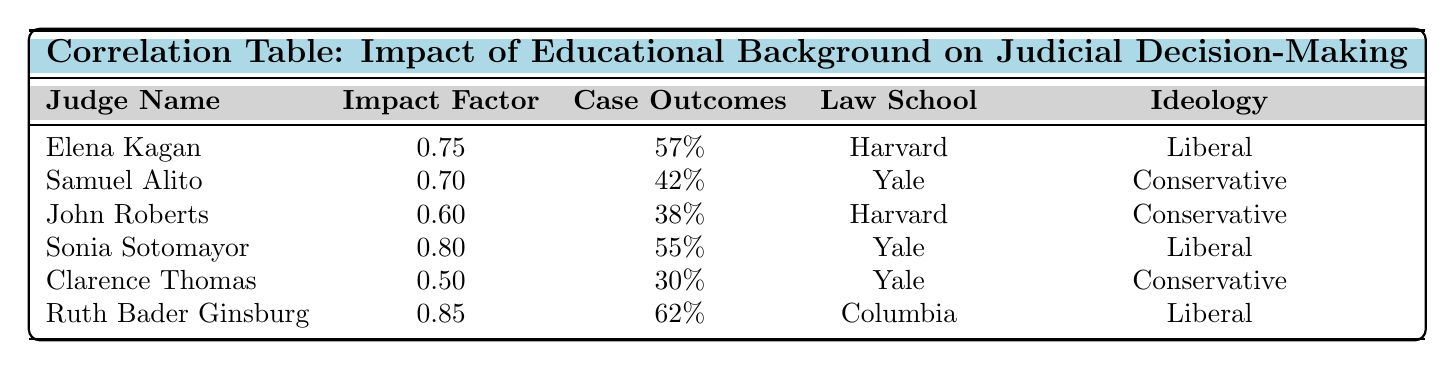What is the impact factor for Ruth Bader Ginsburg? The table lists "Ruth Bader Ginsburg" in the row corresponding to her, and the impact factor is directly shown as 0.85.
Answer: 0.85 Which judge has the highest percentage of favorable case outcomes? By examining the "Case Outcomes" column, Ruth Bader Ginsburg's row indicates 62%, which is the highest percentage in the table when compared to others.
Answer: 62% Is there a judge with a lower impact factor than Clarence Thomas? The impact factor for Clarence Thomas is 0.50. Reviewing the impact factors of all judges listed, there is no entry lower than 0.50 (the next lowest is 0.50 itself).
Answer: No What is the average impact factor of judges from Harvard Law School? The judges from Harvard Law School are Elena Kagan (0.75) and John Roberts (0.60). To calculate the average: (0.75 + 0.60) / 2 = 0.675.
Answer: 0.675 How many judges with a liberal ideology have an impact factor greater than 0.75? The judges with a liberal ideology are Elena Kagan (0.75), Sonia Sotomayor (0.80), and Ruth Bader Ginsburg (0.85). Among them, Sonia Sotomayor and Ruth Bader Ginsburg have impact factors greater than 0.75, making a total of 2 judges who meet this criterion.
Answer: 2 What is the difference in favorable case outcomes between the most and least favorable judges? The most favorable judge is Ruth Bader Ginsburg with 62% favorable case outcomes, and the least favorable is Clarence Thomas with 30%. The difference is 62% - 30% = 32%.
Answer: 32% Which law school produced the most judges in this table? By checking the "Law School" column, Yale Law School is represented by Samuel Alito, Sonia Sotomayor, and Clarence Thomas (3 judges), while Harvard Law School has 2 judges. Therefore, Yale Law School produced the most judges.
Answer: Yale Law School Is the impact factor always associated with favorable case outcomes? No, looking at the "Impact Factor" and "Case Outcomes," it can be noted that although Ruth Bader Ginsburg has the highest impact factor of 0.85 and favorable outcomes of 62%, Clarence Thomas has the lowest impact factor of 0.50 and also the least favorable outcomes of 30%. Hence, there's no direct correlation in all cases.
Answer: No 